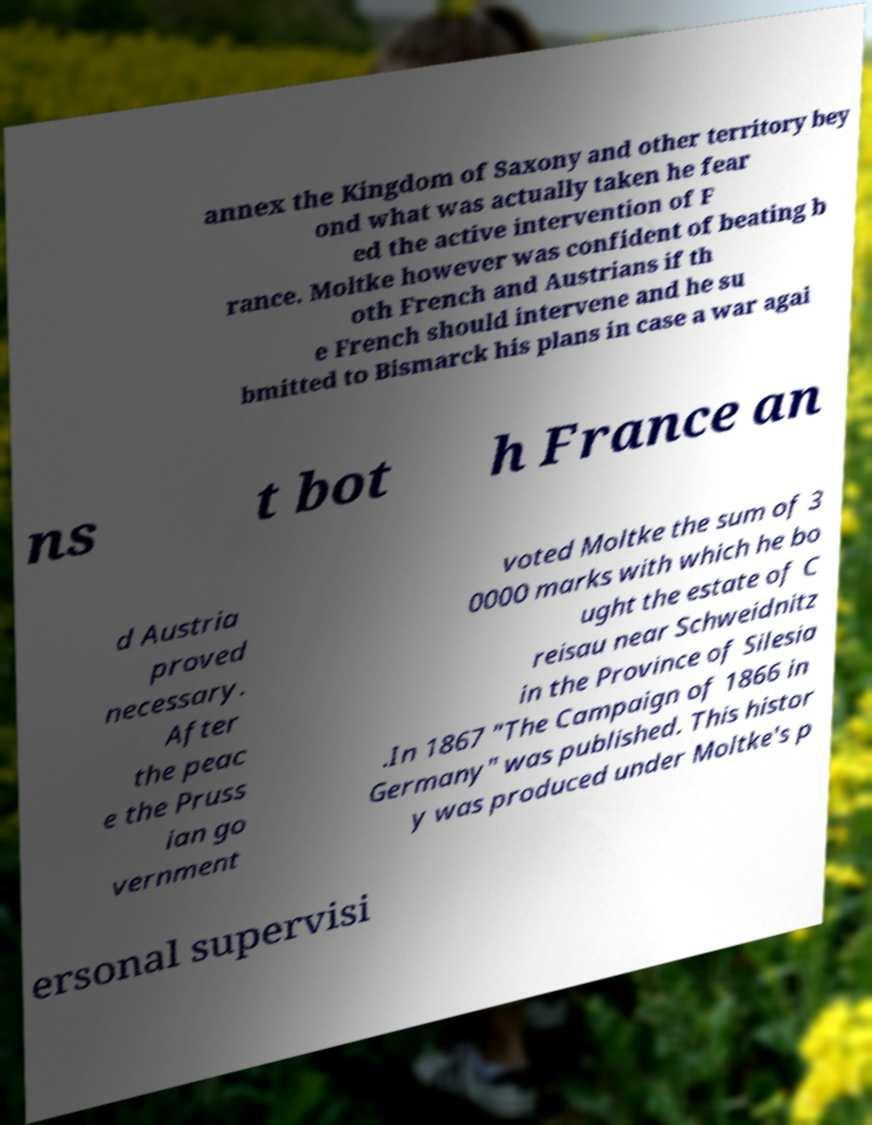Could you extract and type out the text from this image? annex the Kingdom of Saxony and other territory bey ond what was actually taken he fear ed the active intervention of F rance. Moltke however was confident of beating b oth French and Austrians if th e French should intervene and he su bmitted to Bismarck his plans in case a war agai ns t bot h France an d Austria proved necessary. After the peac e the Pruss ian go vernment voted Moltke the sum of 3 0000 marks with which he bo ught the estate of C reisau near Schweidnitz in the Province of Silesia .In 1867 "The Campaign of 1866 in Germany" was published. This histor y was produced under Moltke's p ersonal supervisi 